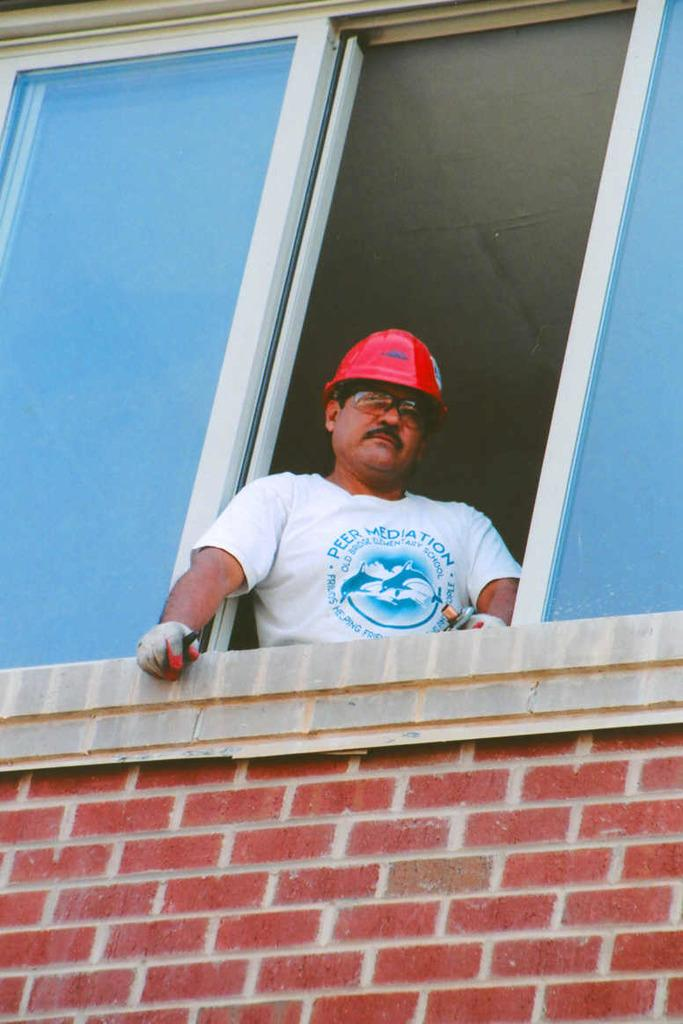Who is present in the image? There is a man in the image. What is the man doing in the image? The man is peeping through a window. What protective gear is the man wearing in the image? The man is wearing gloves, goggles, and a helmet in the image. What type of insect can be seen crawling on the man's feet in the image? There is no insect visible on the man's feet in the image. Can you describe the stranger standing next to the man in the image? There is no stranger present in the image; only the man can be seen. 